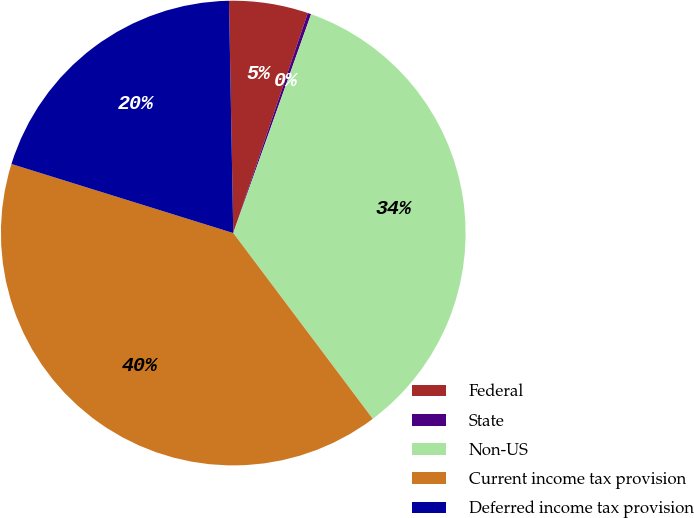Convert chart to OTSL. <chart><loc_0><loc_0><loc_500><loc_500><pie_chart><fcel>Federal<fcel>State<fcel>Non-US<fcel>Current income tax provision<fcel>Deferred income tax provision<nl><fcel>5.49%<fcel>0.24%<fcel>34.31%<fcel>40.05%<fcel>19.9%<nl></chart> 